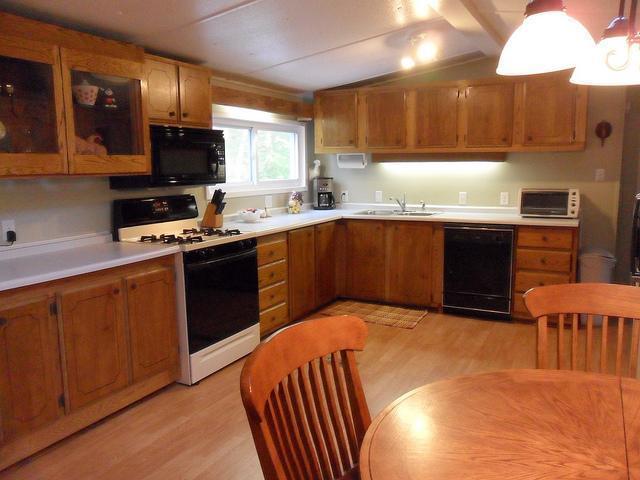What is the silver appliance near the window used to make?
Indicate the correct response by choosing from the four available options to answer the question.
Options: Coffee, donuts, bread, ice cream. Coffee. 